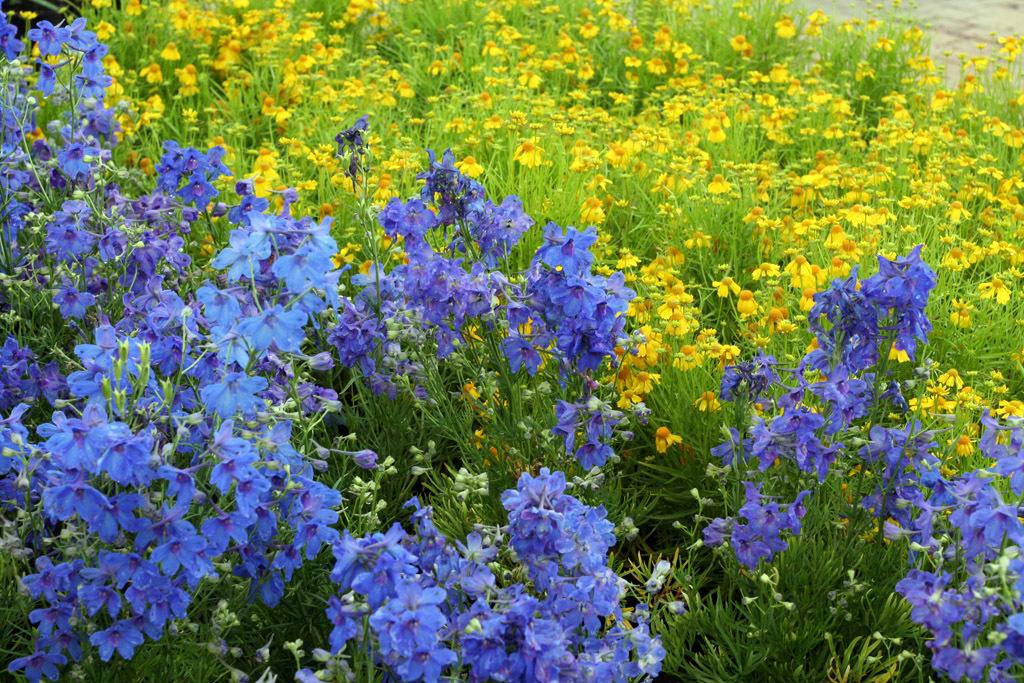What type of living organisms can be seen in the image? Plants and flowers are visible in the image. Can you describe the stage of growth for some of the plants in the image? There are buds in the image, which suggests that some of the plants are in the early stages of growth. What type of shoe can be seen in the image? There is no shoe present in the image; it features plants and flowers. Can you tell me the name of the partner who helped arrange the flowers in the image? There is no information about a partner or any assistance in arranging the flowers in the image. 